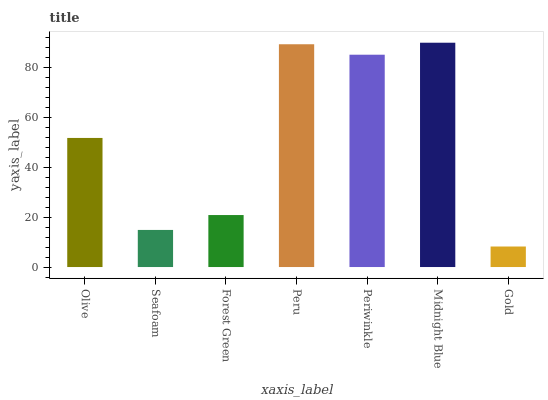Is Gold the minimum?
Answer yes or no. Yes. Is Midnight Blue the maximum?
Answer yes or no. Yes. Is Seafoam the minimum?
Answer yes or no. No. Is Seafoam the maximum?
Answer yes or no. No. Is Olive greater than Seafoam?
Answer yes or no. Yes. Is Seafoam less than Olive?
Answer yes or no. Yes. Is Seafoam greater than Olive?
Answer yes or no. No. Is Olive less than Seafoam?
Answer yes or no. No. Is Olive the high median?
Answer yes or no. Yes. Is Olive the low median?
Answer yes or no. Yes. Is Peru the high median?
Answer yes or no. No. Is Periwinkle the low median?
Answer yes or no. No. 